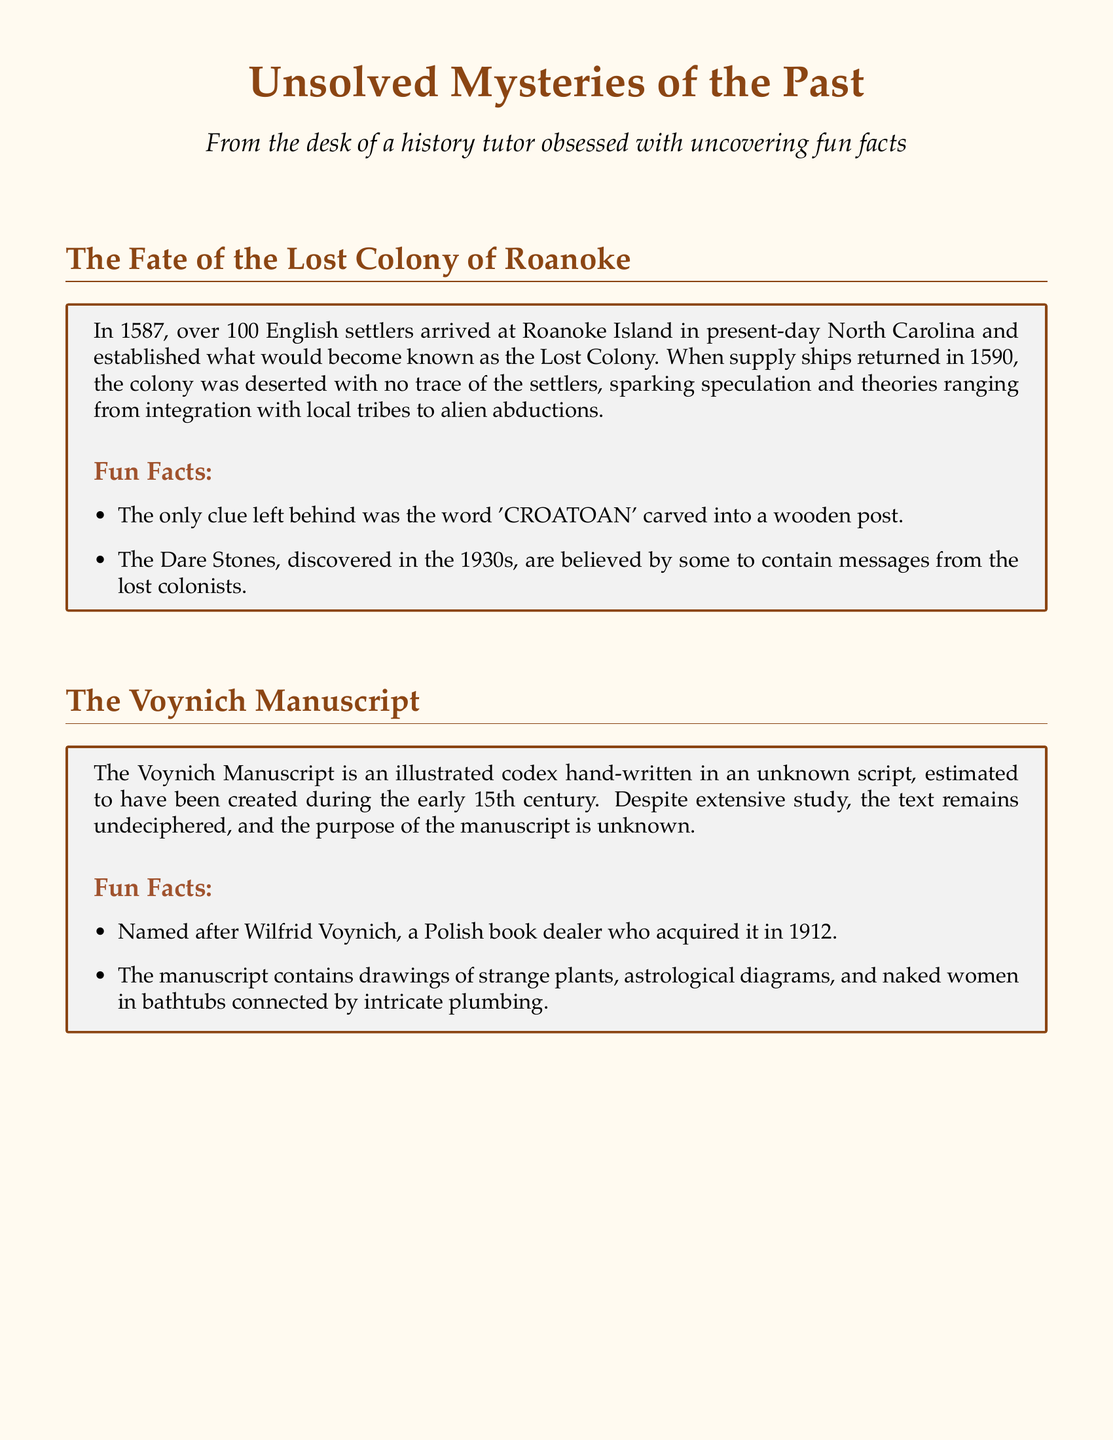What year did the Lost Colony of Roanoke get established? The document states that over 100 English settlers arrived at Roanoke Island in 1587, which is when the colony was established.
Answer: 1587 What was the only clue left behind by the Roanoke settlers? The document mentions that the only clue was the word 'CROATOAN' carved into a wooden post.
Answer: 'CROATOAN' Who acquired the Voynich Manuscript in 1912? According to the document, the manuscript is named after Wilfrid Voynich, a Polish book dealer who acquired it.
Answer: Wilfrid Voynich What writing system did the Minoans use? The document mentions that the Minoans had a complex writing system known as Linear A.
Answer: Linear A What event possibly caused the decline of the Minoan civilization? The document states that the decline may have been due to a massive volcanic eruption on the nearby island of Thera.
Answer: Volcanic eruption List one type of illustration found in the Voynich Manuscript. The document notes that the manuscript contains drawings of strange plants among other things.
Answer: Strange plants What is another term used to refer to Akrotiri in the context of the Minoans? The document refers to Akrotiri as the 'Minoan Pompeii,' which highlights its preserved state after being buried.
Answer: 'Minoan Pompeii' What is the primary mystery surrounding the Voynich Manuscript? The document indicates that the text of the Voynich Manuscript remains undeciphered, signifying its mystery.
Answer: Undeciphered 